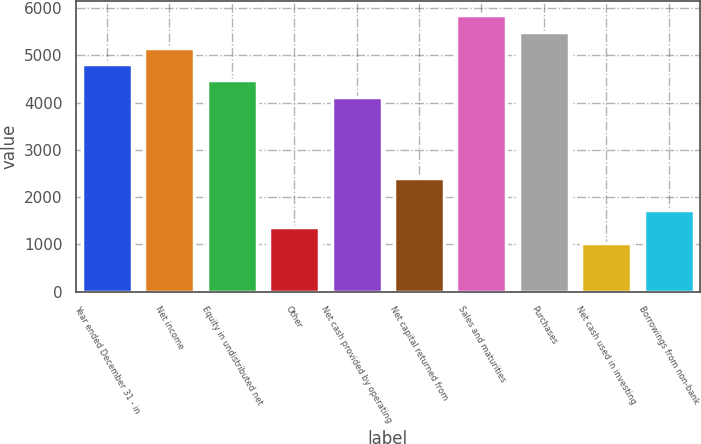<chart> <loc_0><loc_0><loc_500><loc_500><bar_chart><fcel>Year ended December 31 - in<fcel>Net income<fcel>Equity in undistributed net<fcel>Other<fcel>Net cash provided by operating<fcel>Net capital returned from<fcel>Sales and maturities<fcel>Purchases<fcel>Net cash used in investing<fcel>Borrowings from non-bank<nl><fcel>4815.6<fcel>5159.5<fcel>4471.7<fcel>1376.6<fcel>4127.8<fcel>2408.3<fcel>5847.3<fcel>5503.4<fcel>1032.7<fcel>1720.5<nl></chart> 